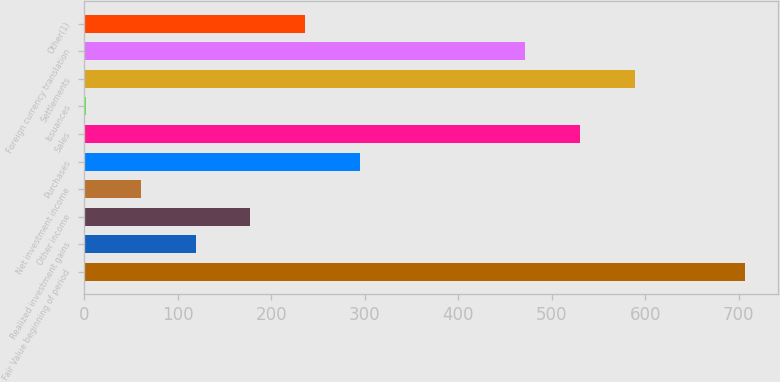<chart> <loc_0><loc_0><loc_500><loc_500><bar_chart><fcel>Fair Value beginning of period<fcel>Realized investment gains<fcel>Other income<fcel>Net investment income<fcel>Purchases<fcel>Sales<fcel>Issuances<fcel>Settlements<fcel>Foreign currency translation<fcel>Other(1)<nl><fcel>706.45<fcel>119.28<fcel>178<fcel>60.57<fcel>295.44<fcel>530.3<fcel>1.85<fcel>589.01<fcel>471.59<fcel>236.72<nl></chart> 